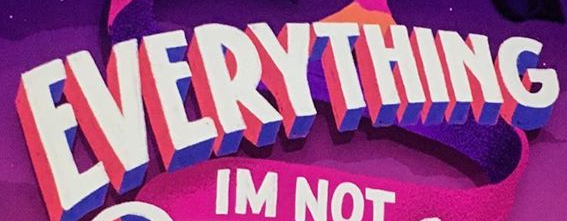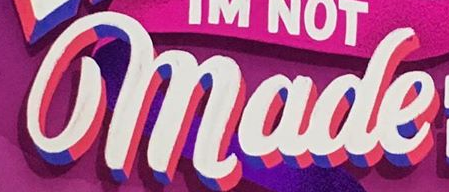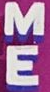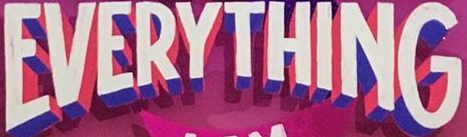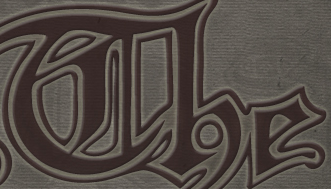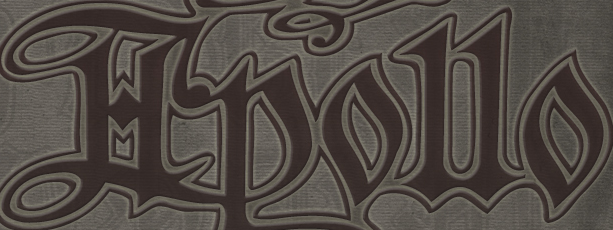What text is displayed in these images sequentially, separated by a semicolon? EVERYTHING; made; ME; EVERYTHING; The; Hpollo 